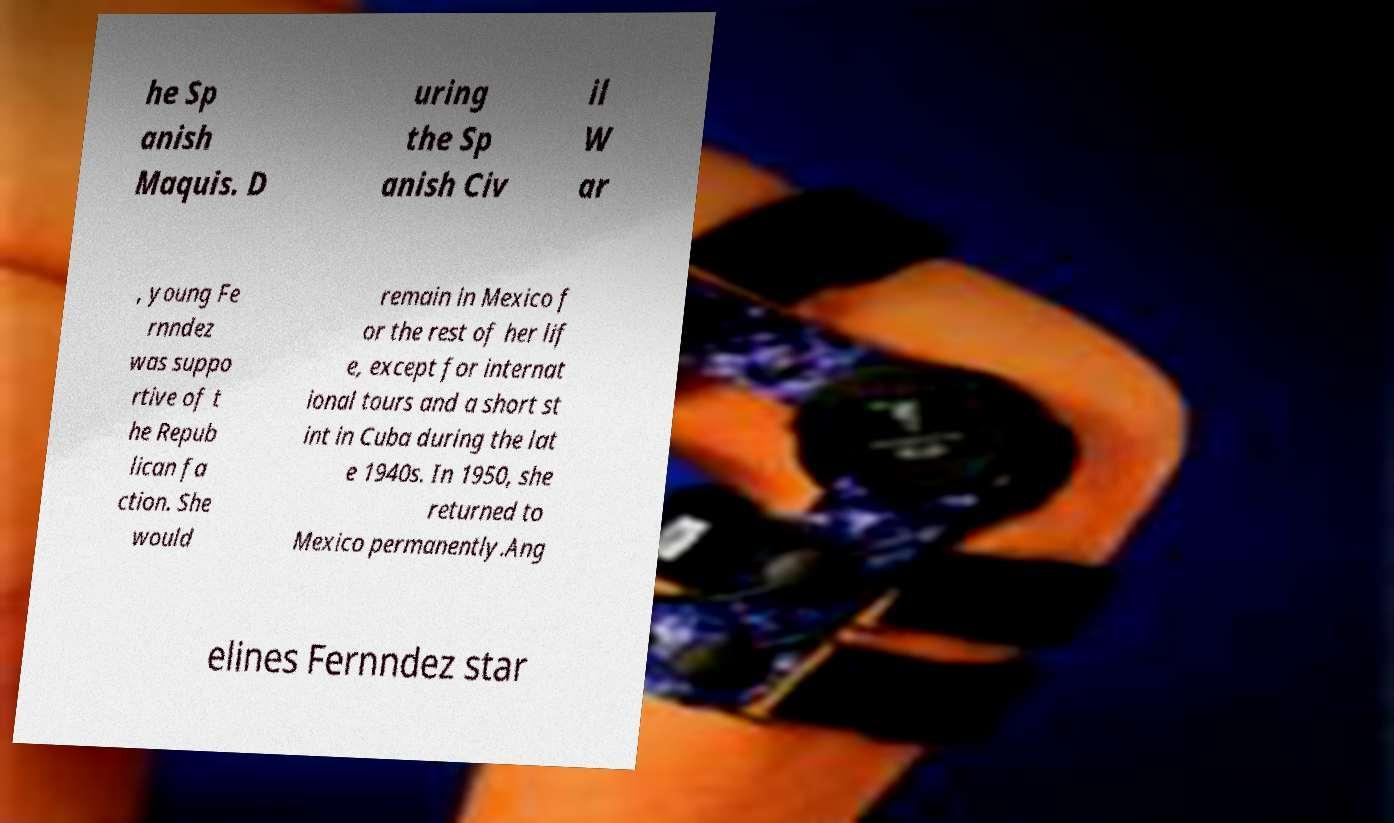What messages or text are displayed in this image? I need them in a readable, typed format. he Sp anish Maquis. D uring the Sp anish Civ il W ar , young Fe rnndez was suppo rtive of t he Repub lican fa ction. She would remain in Mexico f or the rest of her lif e, except for internat ional tours and a short st int in Cuba during the lat e 1940s. In 1950, she returned to Mexico permanently.Ang elines Fernndez star 